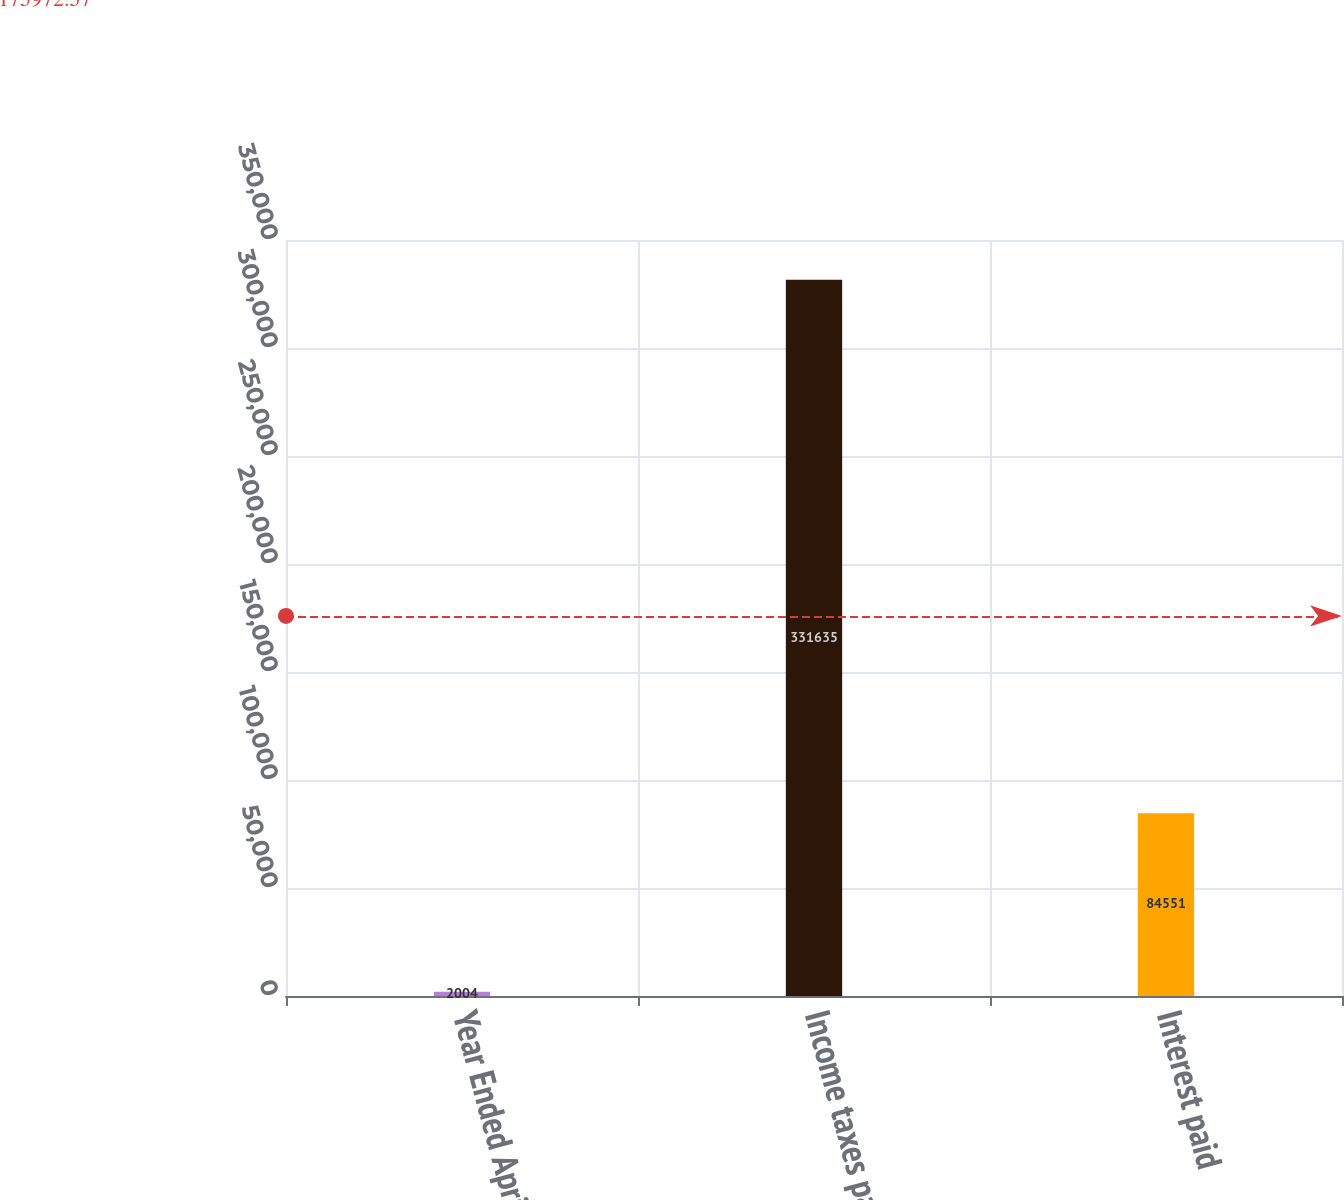Convert chart. <chart><loc_0><loc_0><loc_500><loc_500><bar_chart><fcel>Year Ended April 30<fcel>Income taxes paid<fcel>Interest paid<nl><fcel>2004<fcel>331635<fcel>84551<nl></chart> 